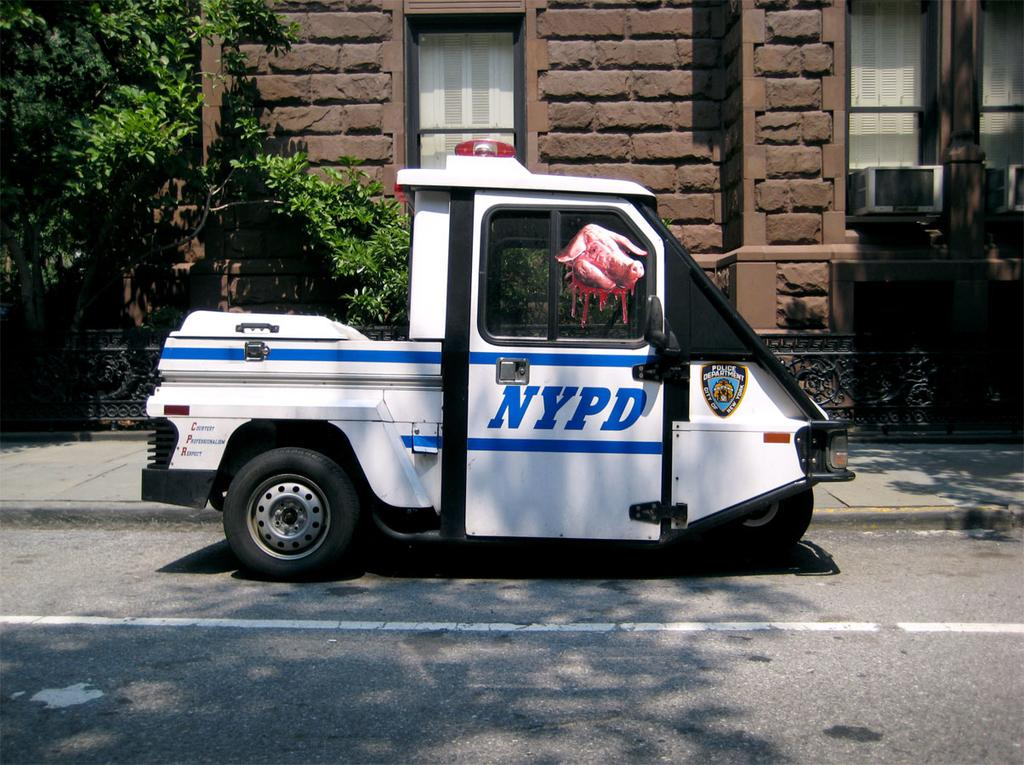What is the main subject in the center of the image? There is a vehicle in the center of the image. What can be seen in the background of the image? There is a house, a window, an air conditioner, and trees in the background of the image. What is at the bottom of the image? There is a road at the bottom of the image. Where is the door to the club located in the image? There is no door or club present in the image. What is the edge of the image used for? The edge of the image is not a physical object or feature in the scene; it is simply the boundary of the photograph. 